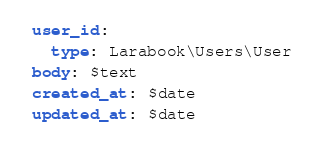<code> <loc_0><loc_0><loc_500><loc_500><_YAML_> user_id:
   type: Larabook\Users\User
 body: $text
 created_at: $date
 updated_at: $date</code> 